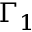Convert formula to latex. <formula><loc_0><loc_0><loc_500><loc_500>\Gamma _ { 1 }</formula> 